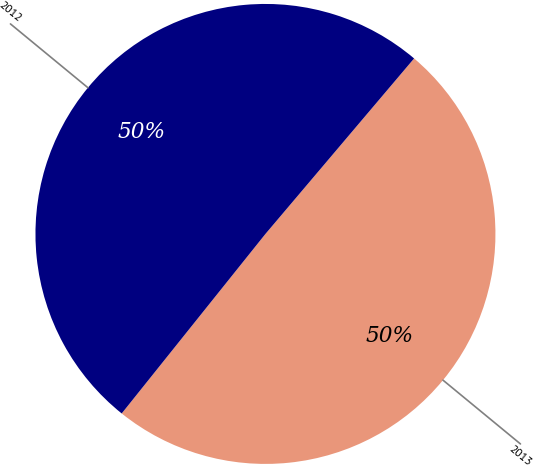<chart> <loc_0><loc_0><loc_500><loc_500><pie_chart><fcel>2013<fcel>2012<nl><fcel>49.56%<fcel>50.44%<nl></chart> 